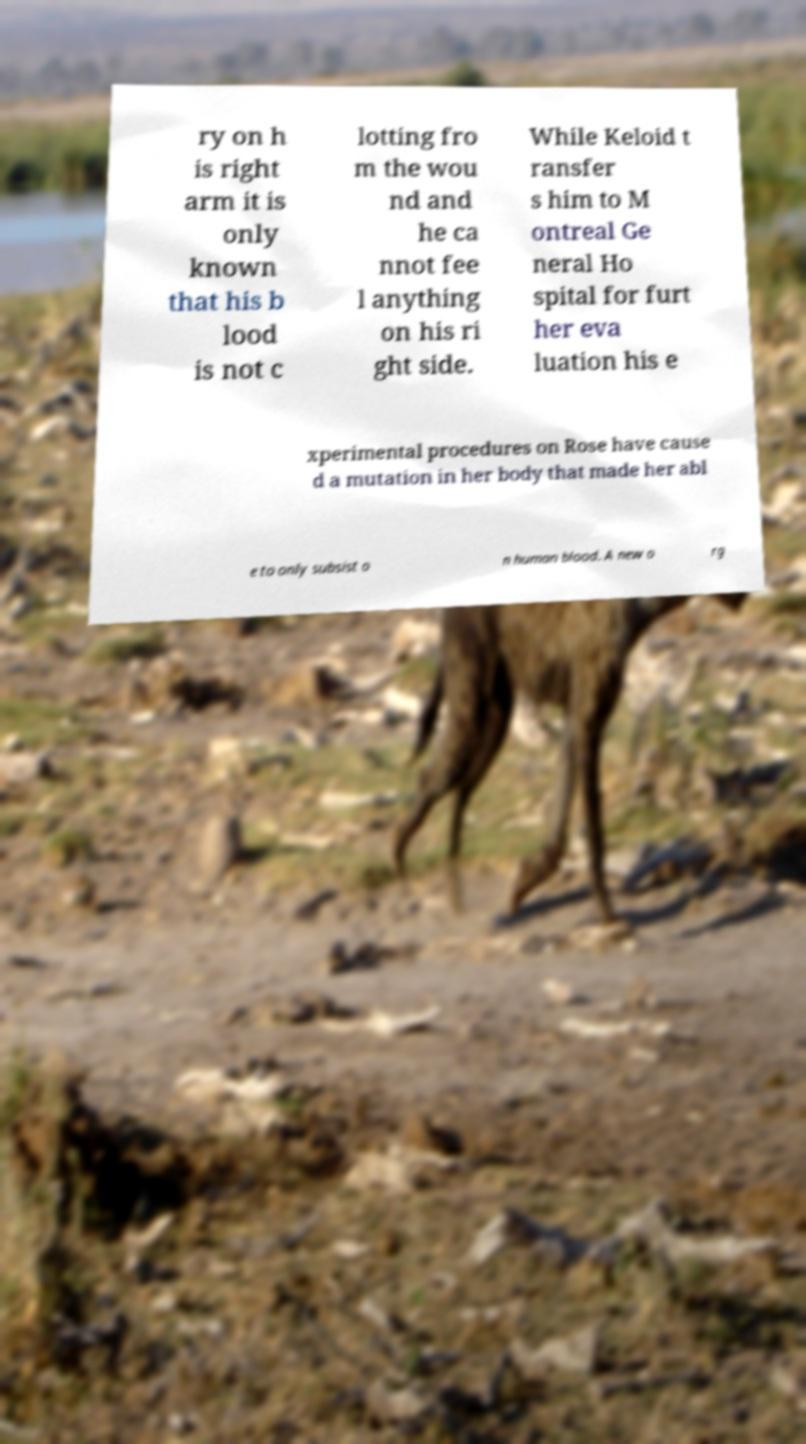What messages or text are displayed in this image? I need them in a readable, typed format. ry on h is right arm it is only known that his b lood is not c lotting fro m the wou nd and he ca nnot fee l anything on his ri ght side. While Keloid t ransfer s him to M ontreal Ge neral Ho spital for furt her eva luation his e xperimental procedures on Rose have cause d a mutation in her body that made her abl e to only subsist o n human blood. A new o rg 